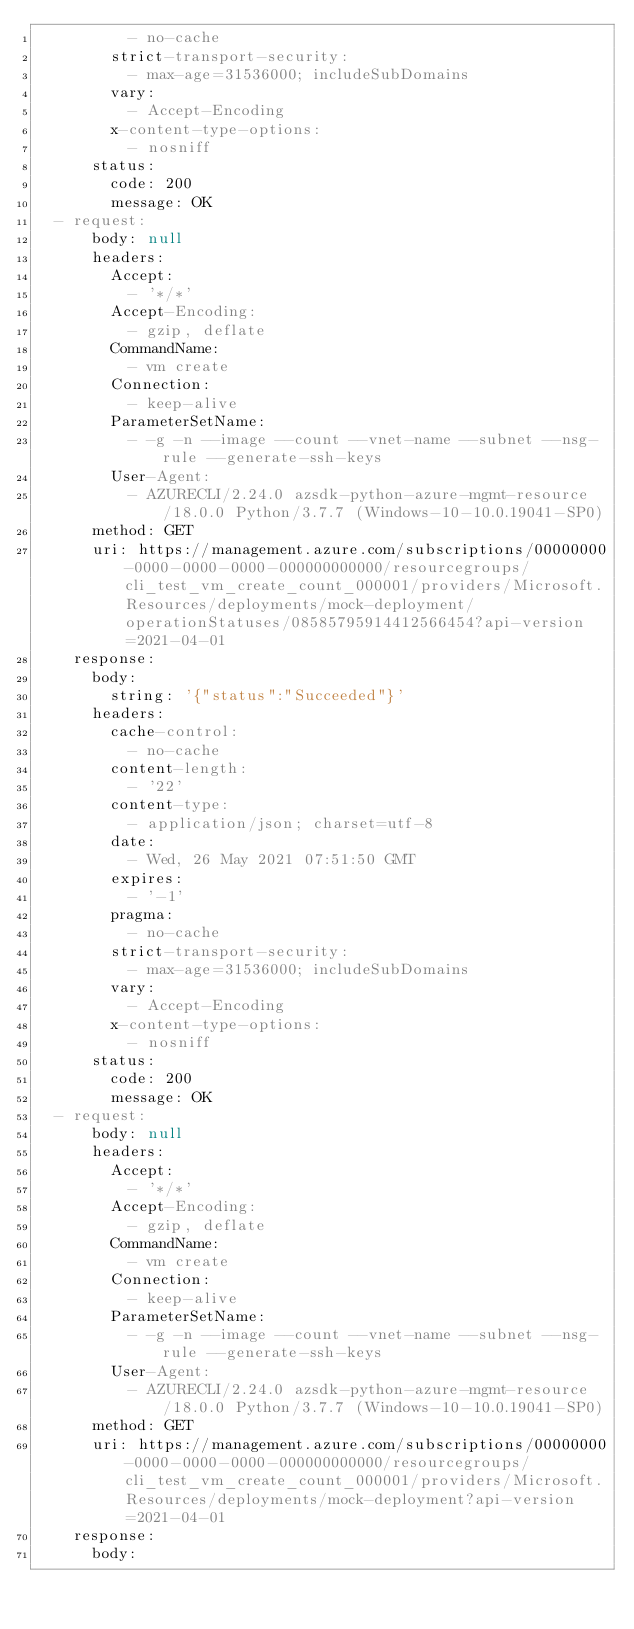<code> <loc_0><loc_0><loc_500><loc_500><_YAML_>          - no-cache
        strict-transport-security:
          - max-age=31536000; includeSubDomains
        vary:
          - Accept-Encoding
        x-content-type-options:
          - nosniff
      status:
        code: 200
        message: OK
  - request:
      body: null
      headers:
        Accept:
          - '*/*'
        Accept-Encoding:
          - gzip, deflate
        CommandName:
          - vm create
        Connection:
          - keep-alive
        ParameterSetName:
          - -g -n --image --count --vnet-name --subnet --nsg-rule --generate-ssh-keys
        User-Agent:
          - AZURECLI/2.24.0 azsdk-python-azure-mgmt-resource/18.0.0 Python/3.7.7 (Windows-10-10.0.19041-SP0)
      method: GET
      uri: https://management.azure.com/subscriptions/00000000-0000-0000-0000-000000000000/resourcegroups/cli_test_vm_create_count_000001/providers/Microsoft.Resources/deployments/mock-deployment/operationStatuses/08585795914412566454?api-version=2021-04-01
    response:
      body:
        string: '{"status":"Succeeded"}'
      headers:
        cache-control:
          - no-cache
        content-length:
          - '22'
        content-type:
          - application/json; charset=utf-8
        date:
          - Wed, 26 May 2021 07:51:50 GMT
        expires:
          - '-1'
        pragma:
          - no-cache
        strict-transport-security:
          - max-age=31536000; includeSubDomains
        vary:
          - Accept-Encoding
        x-content-type-options:
          - nosniff
      status:
        code: 200
        message: OK
  - request:
      body: null
      headers:
        Accept:
          - '*/*'
        Accept-Encoding:
          - gzip, deflate
        CommandName:
          - vm create
        Connection:
          - keep-alive
        ParameterSetName:
          - -g -n --image --count --vnet-name --subnet --nsg-rule --generate-ssh-keys
        User-Agent:
          - AZURECLI/2.24.0 azsdk-python-azure-mgmt-resource/18.0.0 Python/3.7.7 (Windows-10-10.0.19041-SP0)
      method: GET
      uri: https://management.azure.com/subscriptions/00000000-0000-0000-0000-000000000000/resourcegroups/cli_test_vm_create_count_000001/providers/Microsoft.Resources/deployments/mock-deployment?api-version=2021-04-01
    response:
      body:</code> 